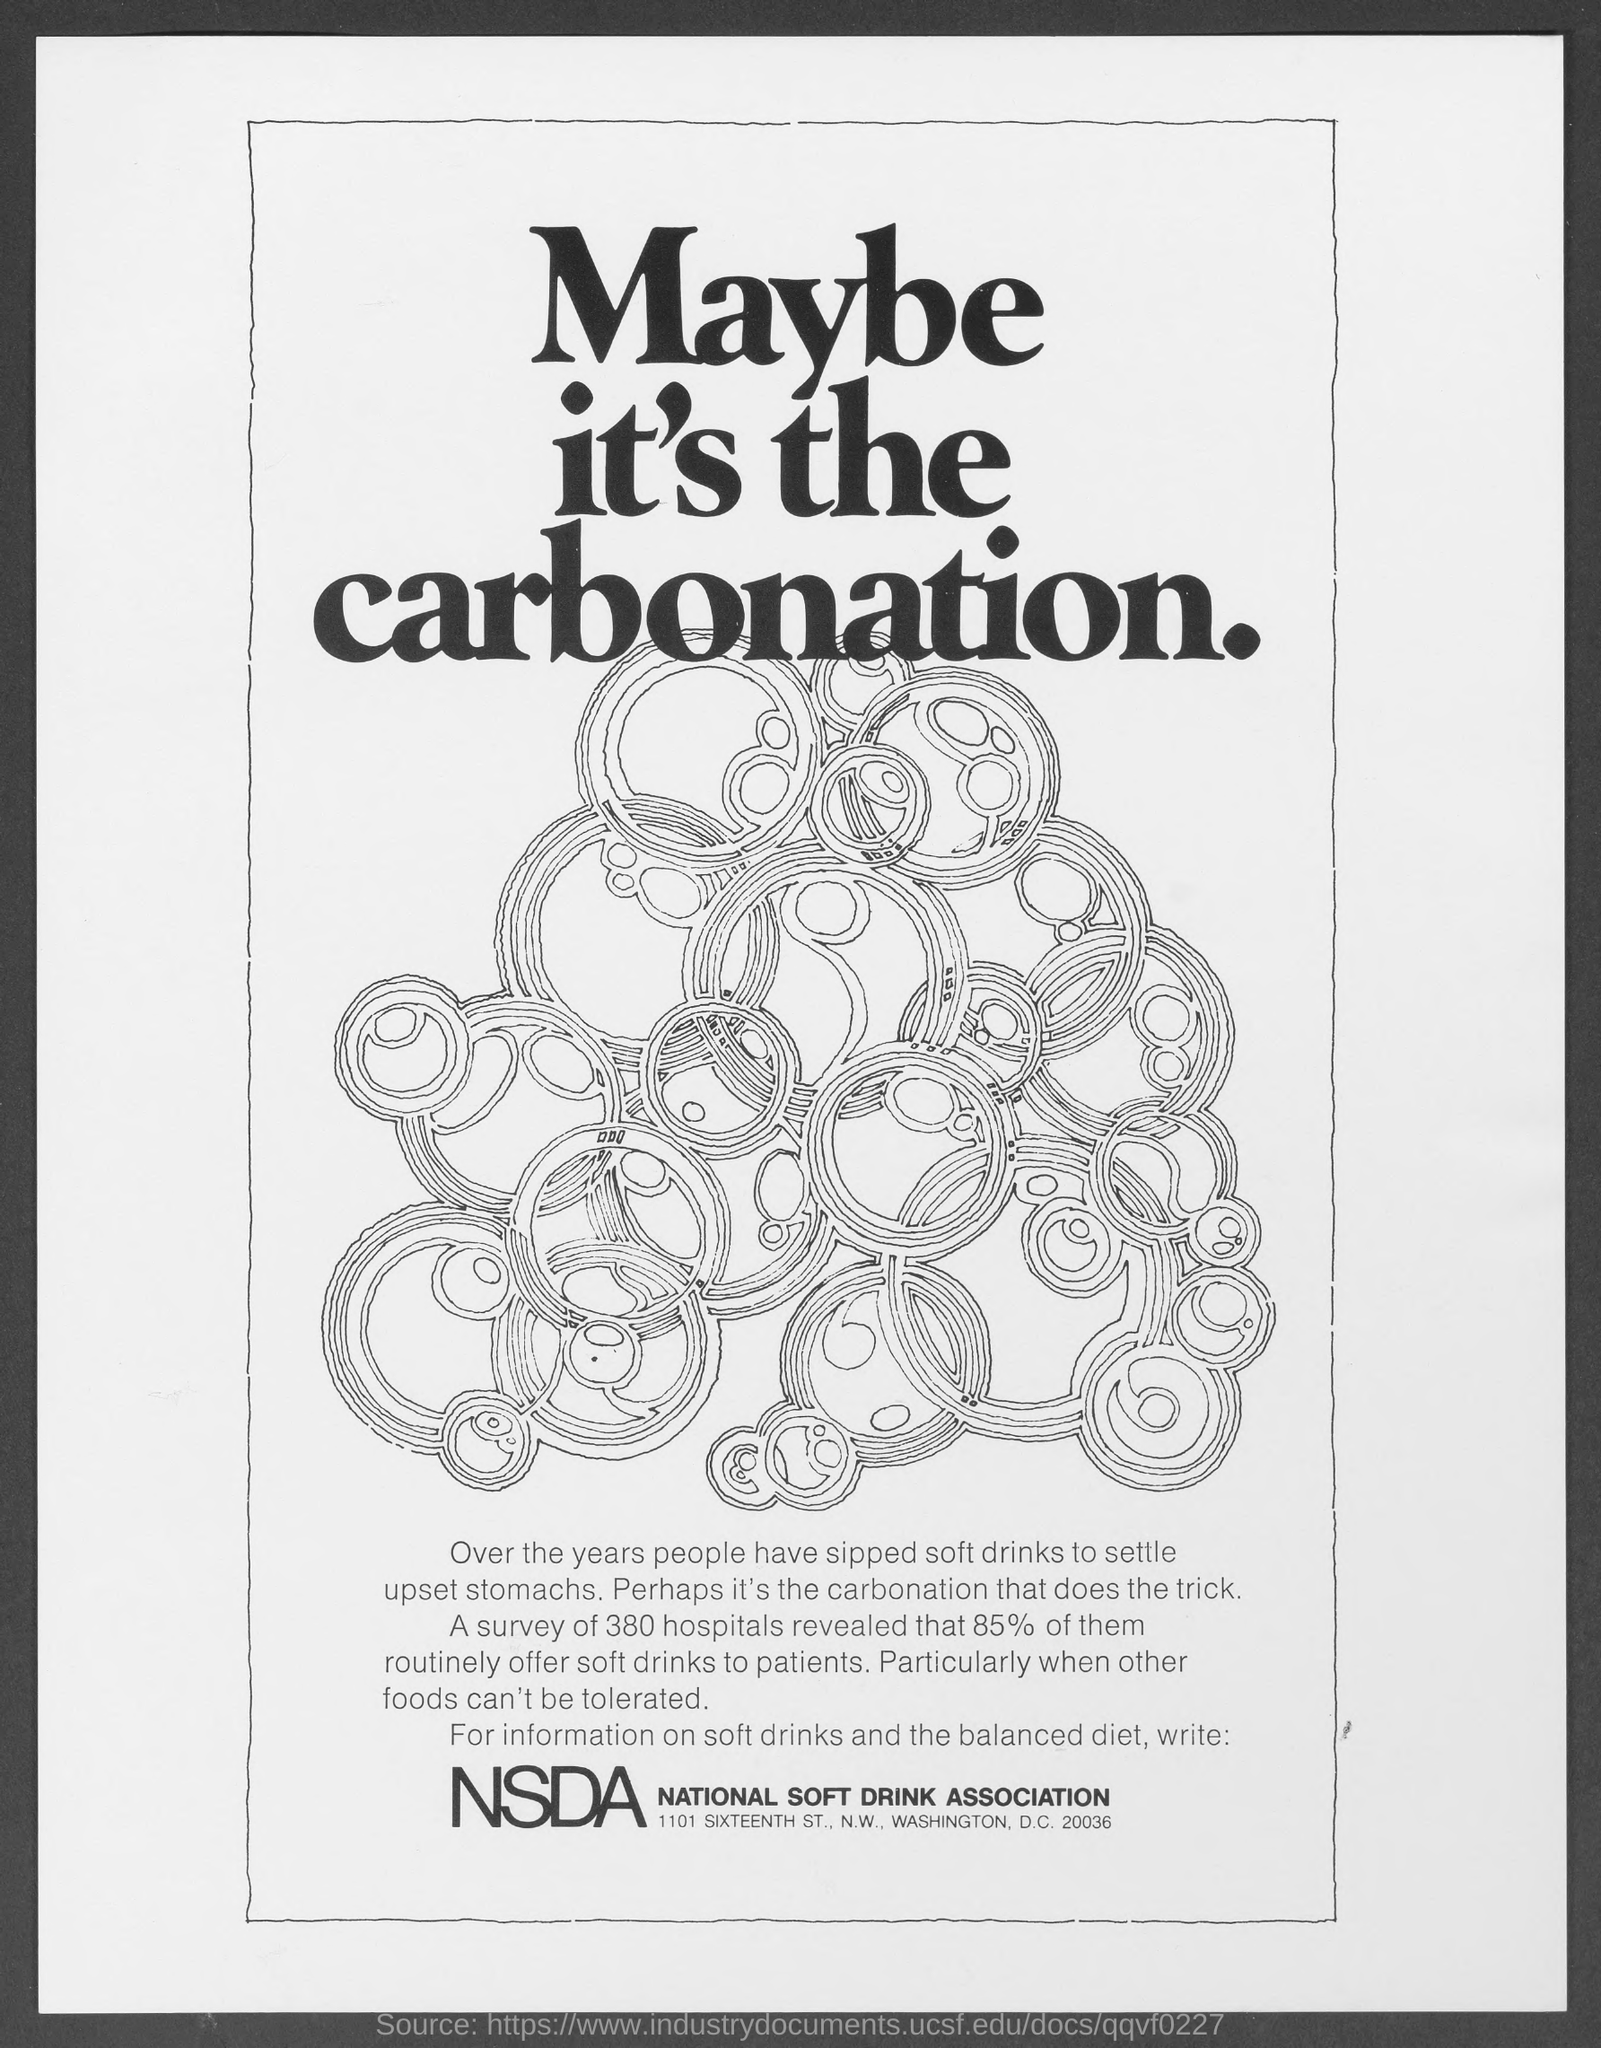What is the sentence written in bold letters, at the top of the figure ?
Provide a short and direct response. Maybe it's the carbonation. What have people sipped over years to settle upset stomachs ?
Your answer should be compact. Soft drinks. How many hospitals were surveyed ?
Keep it short and to the point. 380 hospitals. Out of the 350 hospitals surveyed, what percentage of the hospitals routinely offer soft drinks to the patients
Your answer should be very brief. 85%. 